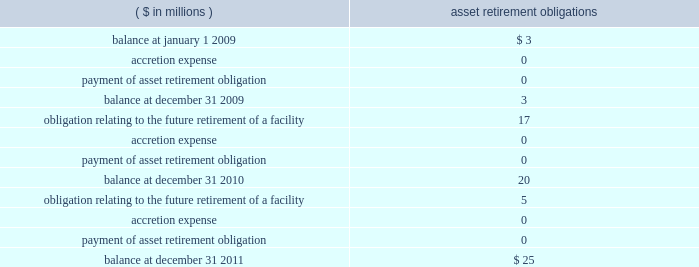Except for long-term debt , the carrying amounts of the company 2019s other financial instruments are measured at fair value or approximate fair value due to the short-term nature of these instruments .
Asset retirement obligations 2014the company records all known asset retirement obligations within other current liabilities for which the liability 2019s fair value can be reasonably estimated , including certain asbestos removal , asset decommissioning and contractual lease restoration obligations .
The changes in the asset retirement obligation carrying amounts during 2011 , 2010 and 2009 were as follows : ( $ in millions ) retirement obligations .
The company also has known conditional asset retirement obligations related to assets currently in use , such as certain asbestos remediation and asset decommissioning activities to be performed in the future , that were not reasonably estimable as of december 31 , 2011 and 2010 , due to insufficient information about the timing and method of settlement of the obligation .
Accordingly , the fair value of these obligations has not been recorded in the consolidated financial statements .
Environmental remediation and/or asset decommissioning of the relevant facilities may be required when the company ceases to utilize these facilities .
In addition , there may be conditional environmental asset retirement obligations that the company has not yet discovered .
Income taxes 2014income tax expense and other income tax related information contained in the financial statements for periods before the spin-off are presented as if the company filed its own tax returns on a stand-alone basis , while similar information for periods after the spin-off reflect the company 2019s positions to be filed in its own tax returns in the future .
Income tax expense and other related information are based on the prevailing statutory rates for u.s .
Federal income taxes and the composite state income tax rate for the company for each period presented .
State and local income and franchise tax provisions are allocable to contracts in process and , accordingly , are included in general and administrative expenses .
Deferred income taxes are recorded when revenues and expenses are recognized in different periods for financial statement purposes than for tax return purposes .
Deferred tax asset or liability account balances are calculated at the balance sheet date using current tax laws and rates in effect .
Determinations of the expected realizability of deferred tax assets and the need for any valuation allowances against these deferred tax assets were evaluated based upon the stand-alone tax attributes of the company , and an $ 18 million valuation allowance was deemed necessary as of december 31 , 2011 .
No valuation allowance was deemed necessary as of december 31 , 2010 .
Uncertain tax positions meeting the more-likely-than-not recognition threshold , based on the merits of the position , are recognized in the financial statements .
We recognize the amount of tax benefit that is greater than 50% ( 50 % ) likely to be realized upon ultimate settlement with the related tax authority .
If a tax position does not meet the minimum statutory threshold to avoid payment of penalties , we recognize an expense for the amount of the penalty in the period the tax position is claimed or expected to be claimed in our tax return .
Penalties , if probable and reasonably estimable , are recognized as a component of income tax expense .
We also recognize accrued interest related to uncertain tax positions in income tax expense .
The timing and amount of accrued interest is determined by the applicable tax law associated with an underpayment of income taxes .
See note 12 : income taxes .
Under existing gaap , changes in accruals associated with uncertainties are recorded in earnings in the period they are determined. .
Now much of the net increase in aro during the period was due to accretion , in millions? 
Computations: (((0 + 0) + (0 + 0)) / (25 - 3))
Answer: 0.0. 